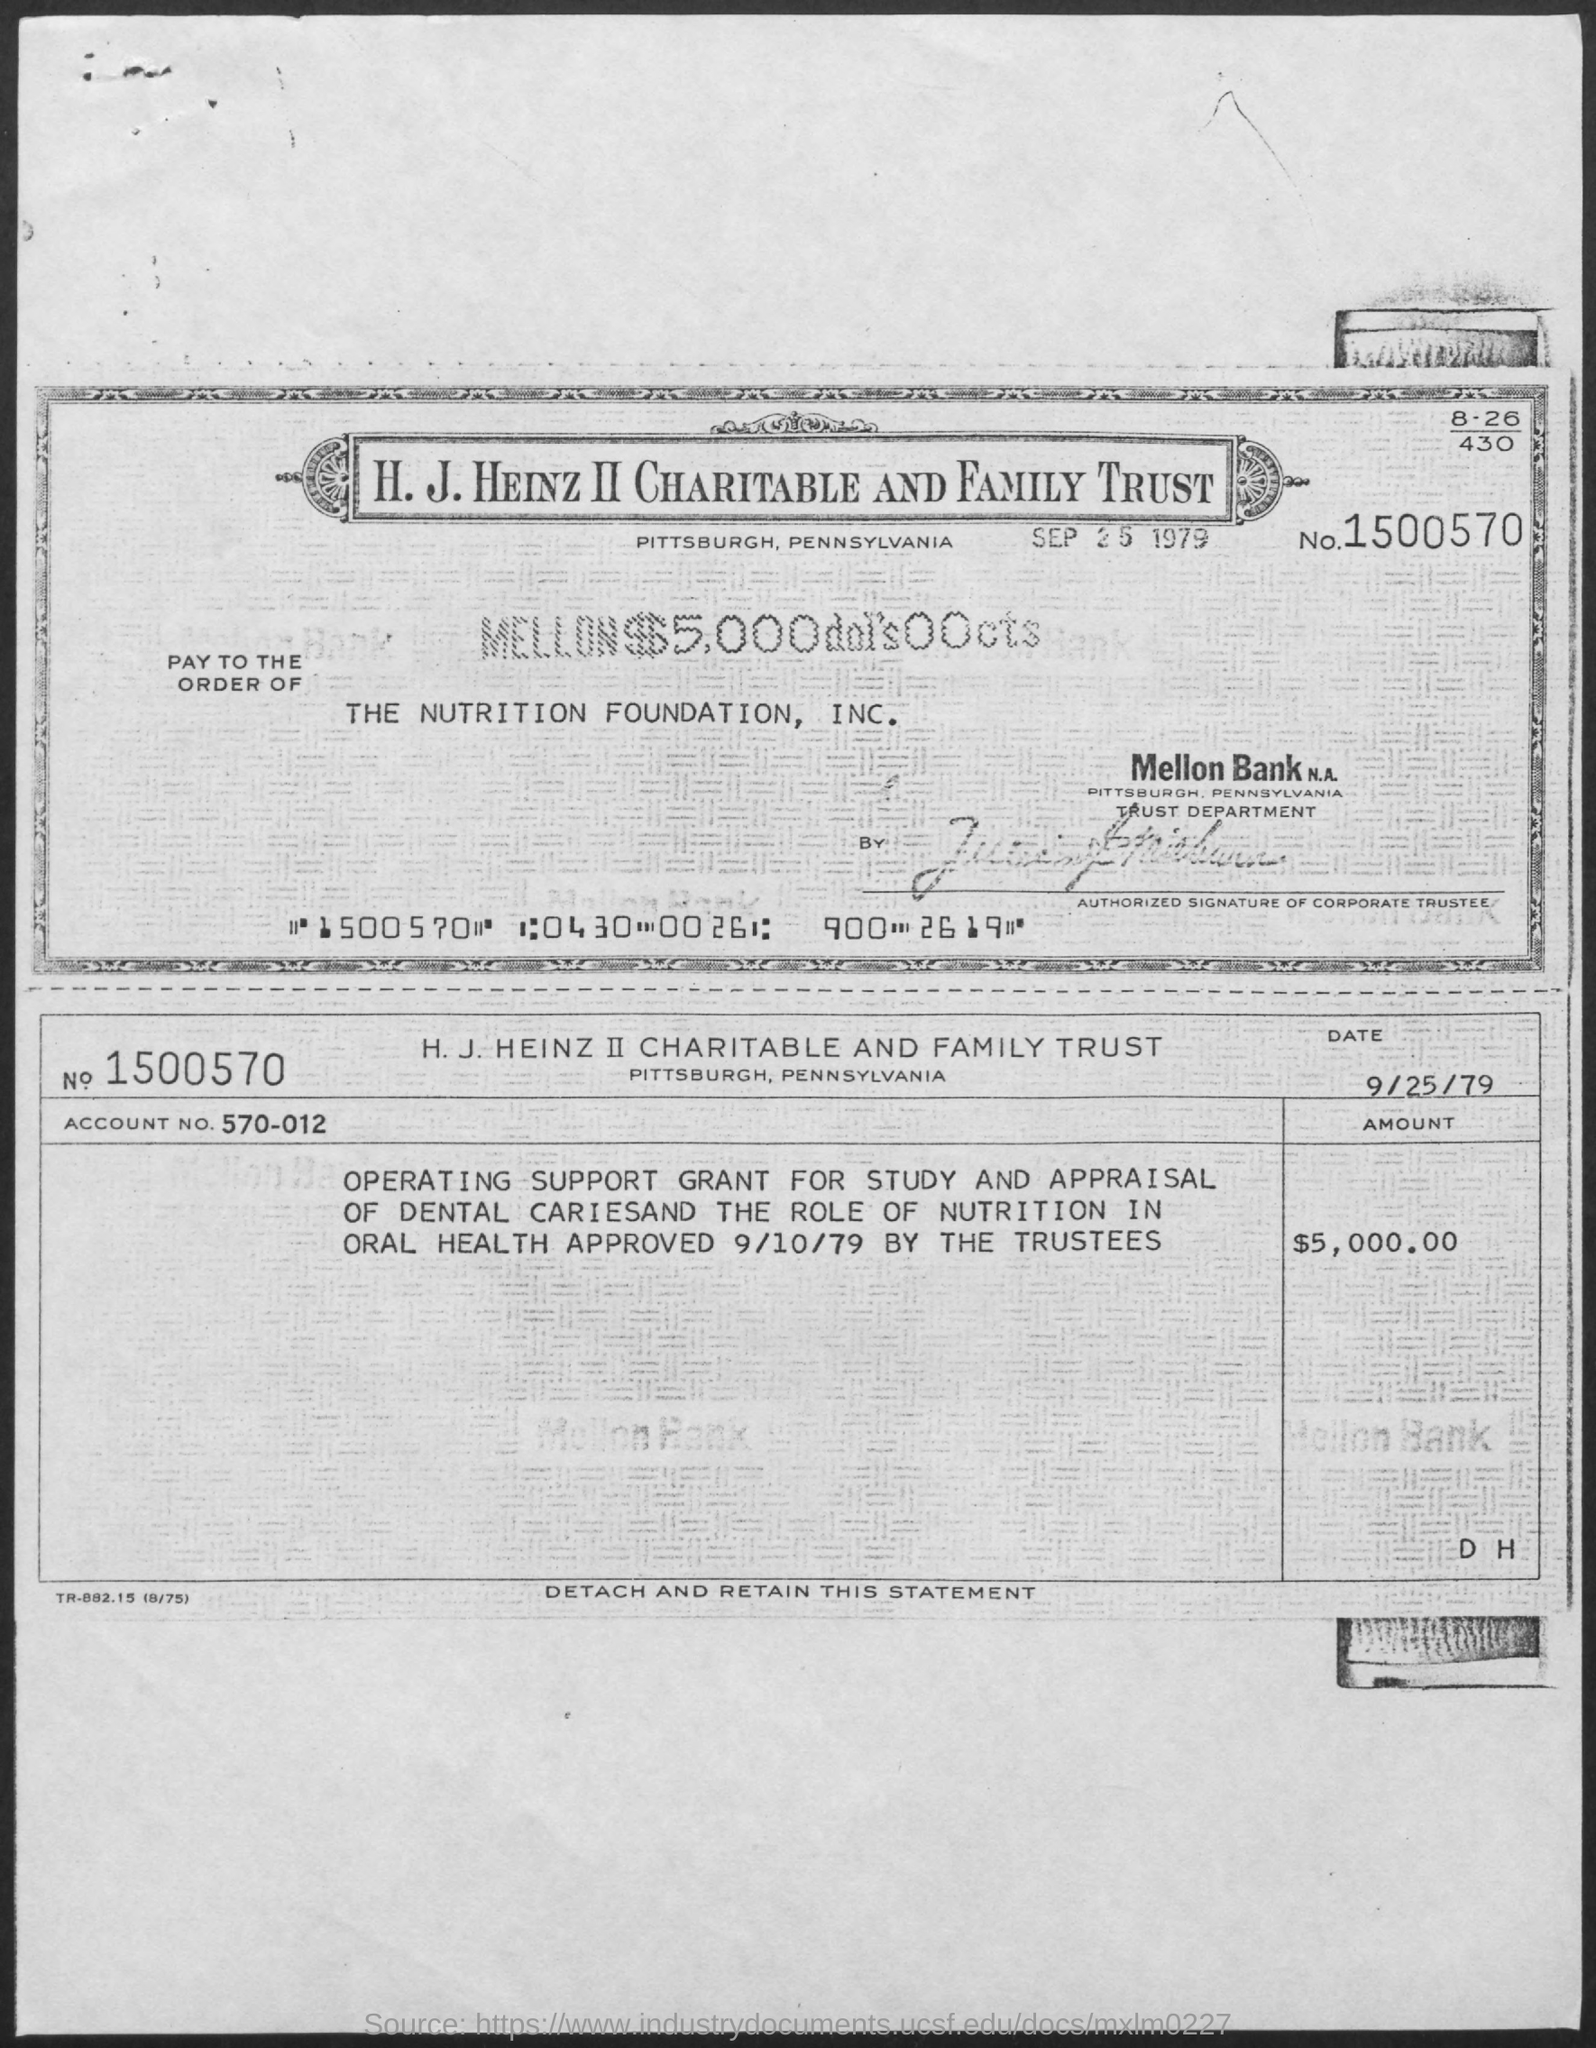Identify some key points in this picture. The amount mentioned is 5,000.00... The H.J. HEINZ II CHARITABLE AND FAMILY TRUST is located in Pittsburgh, Pennsylvania. The account number given is 570-012. I, [Your name], declare that on [September 25, 1979], the H.J. HEINZ II CHARITABLE AND FAMILY TRUST was established. The sum of $5,000 has been paid to The Nutrition Foundation, Inc. 